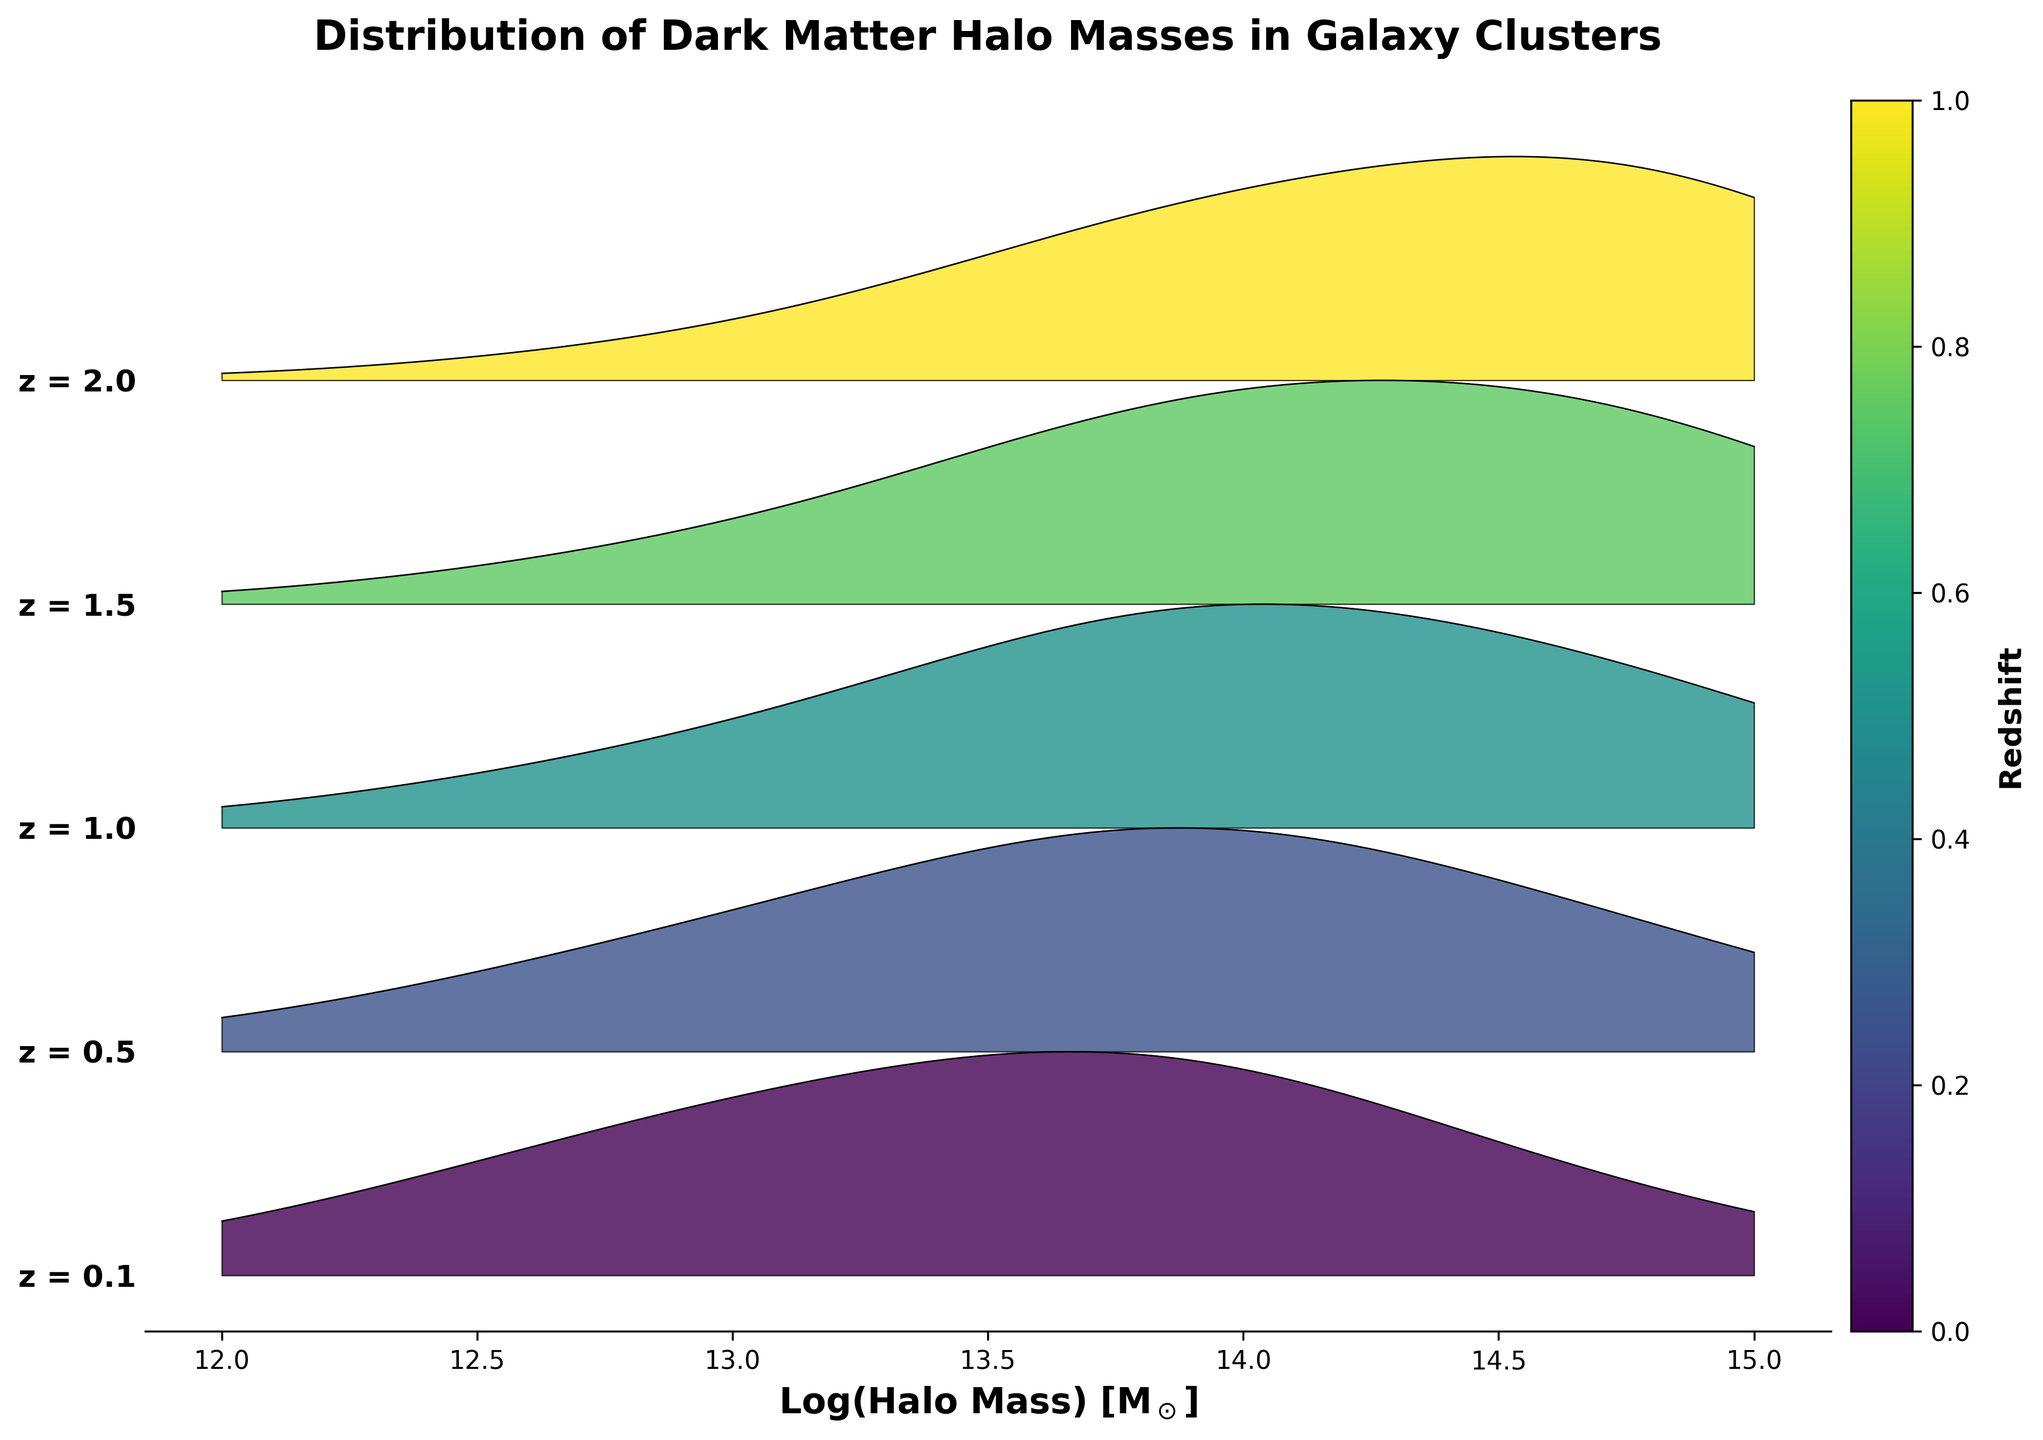What's the title of the plot? The title of the plot is written at the top of the figure.
Answer: Distribution of Dark Matter Halo Masses in Galaxy Clusters What is the x-axis label? The x-axis label is situated below the horizontal axis and describes the data plotted along that axis.
Answer: Log(Halo Mass) [M$_\odot$] How many redshifts are represented in the plot? The plot has different layers for different redshift values, and each layer is indicated by both the color and the y-axis label.
Answer: 5 Which redshift value has the highest density peak at log(Halo Mass) = 14? To determine this, look for the peak that reaches the highest point on the ridgeline plot at log(Halo Mass) = 14. The area under the curve that's highest will indicate the maximum density.
Answer: 2.0 Compare the peak density values at z = 0.1 and z = 1.0. Which is higher? The height of the ridgeline corresponds to the density. By comparing the height of the peaks for z = 0.1 and z = 1.0, you can determine which one is higher.
Answer: z = 1.0 What is the trend in the peak position of halo mass distribution as the redshift increases? Observe the position of the peaks along the x-axis (log(Halo Mass)) as you move from lower to higher redshifts on the y-axis. The shift in peak positions will indicate the trend.
Answer: Peaks shift to higher halo masses At which redshift do we observe the lowest density for halo masses? Identify the redshift layer where the overall plot heights are the smallest, indicating the lowest densities for halo masses.
Answer: 2.0 Which redshift has the widest spread in halo mass distribution? By assessing the width of the curve for each redshift, you can determine the range of halo mass values from mass peaks to the tails. The widest spread indicates a large variation in halo mass distributions.
Answer: 0.5 Is there a notable difference between the density distribution of halo masses at z = 1.5 and z = 2.0? Compare the shape and height of the ridgeline for z = 1.5 and z = 2.0. These differences will illustrate any notable deviations in density distributions between these two redshifts.
Answer: Yes, z = 1.5 shows a more bell-shaped distribution, while z = 2.0 shows a more skewed distribution with a prominent peak at higher masses How does the density of halo masses at low redshifts (z = 0.1) compare to high redshifts (z = 2.0)? Evaluate both the height and spread of the ridgeline plots at these redshift extremes. This comparison will reveal the density characteristics at low versus high redshifts.
Answer: Higher density at z = 0.1, lower and more skewed at z = 2.0 